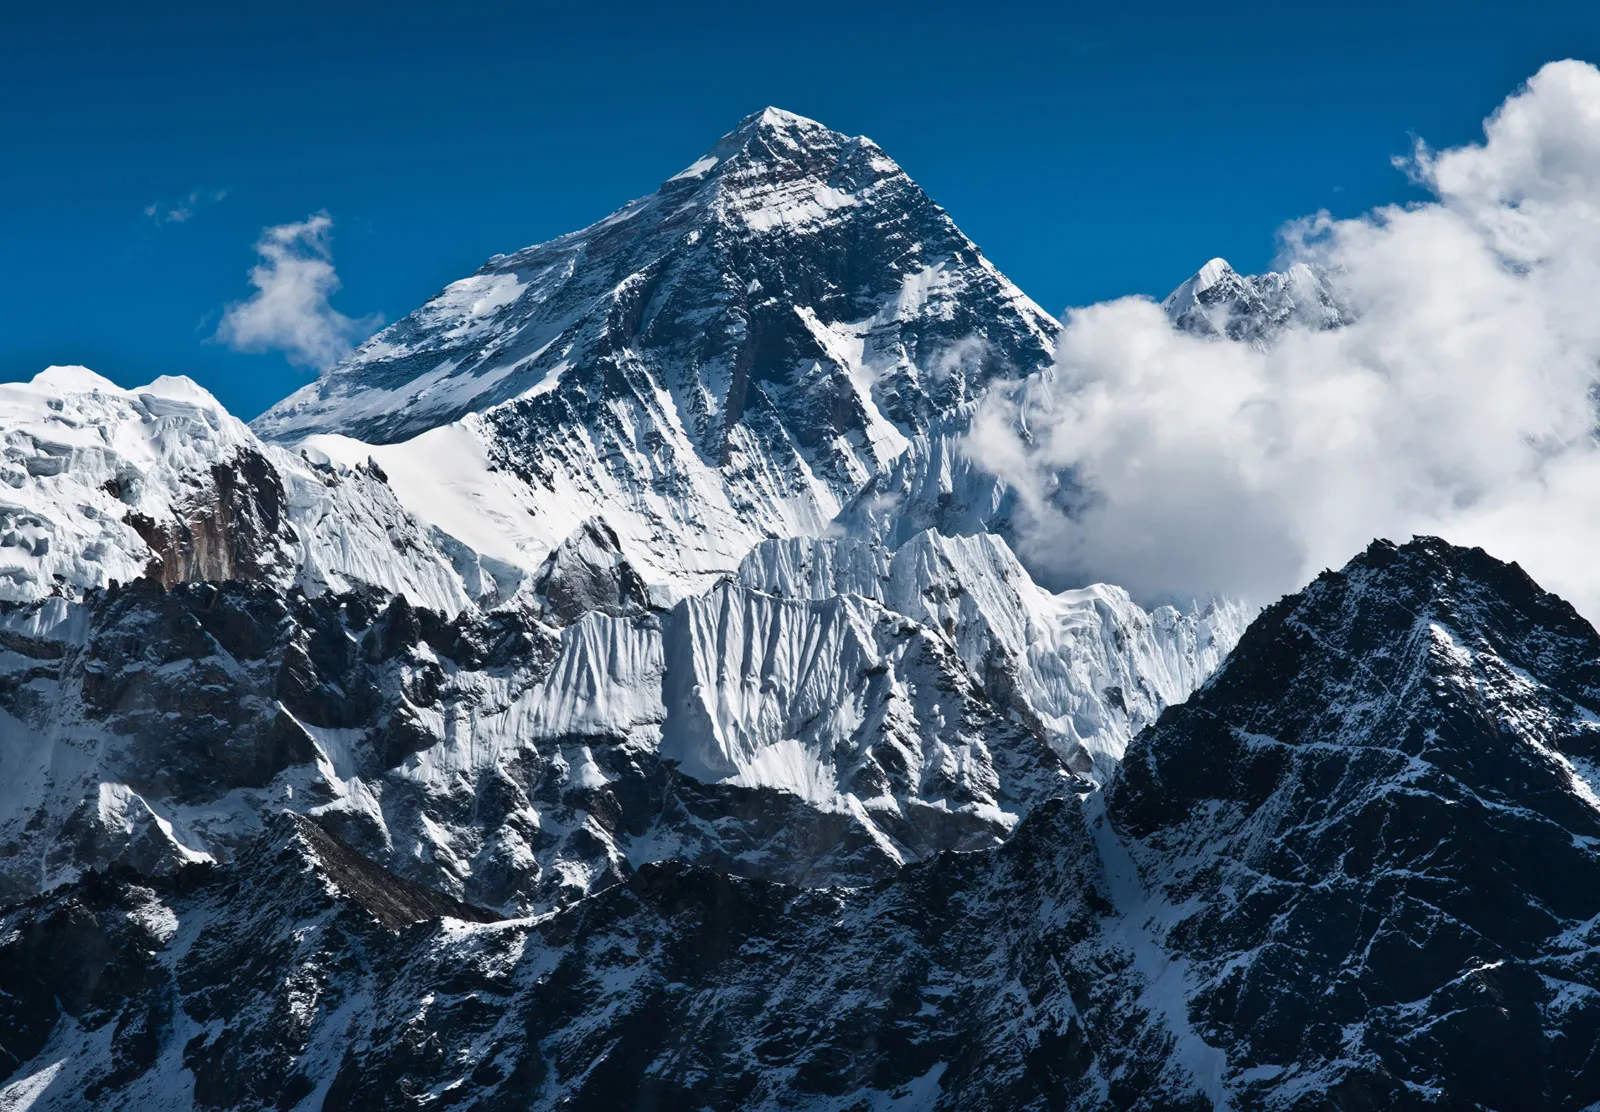Describe the challenges climbers face when attempting to summit Mount Everest. Climbers attempting to summit Mount Everest face an array of daunting challenges. The high altitude and corresponding low oxygen levels make breathing difficult, requiring acclimatization and supplemental oxygen. Extreme weather conditions, including unpredictable snowstorms and temperatures that can drop to -60°C, test the limits of endurance and survival. The physical demand of the climb itself is relentless, with steep, icy slopes and dangerous crevasses presenting constant hazards. The notorious 'Death Zone,' above 8,000 meters, adds relentless pressure with its perilous combination of altitude sickness, fatigue, and limited rescue possibilities. Navigating these challenges requires not only physical fitness but also mental resilience and meticulous preparation. 